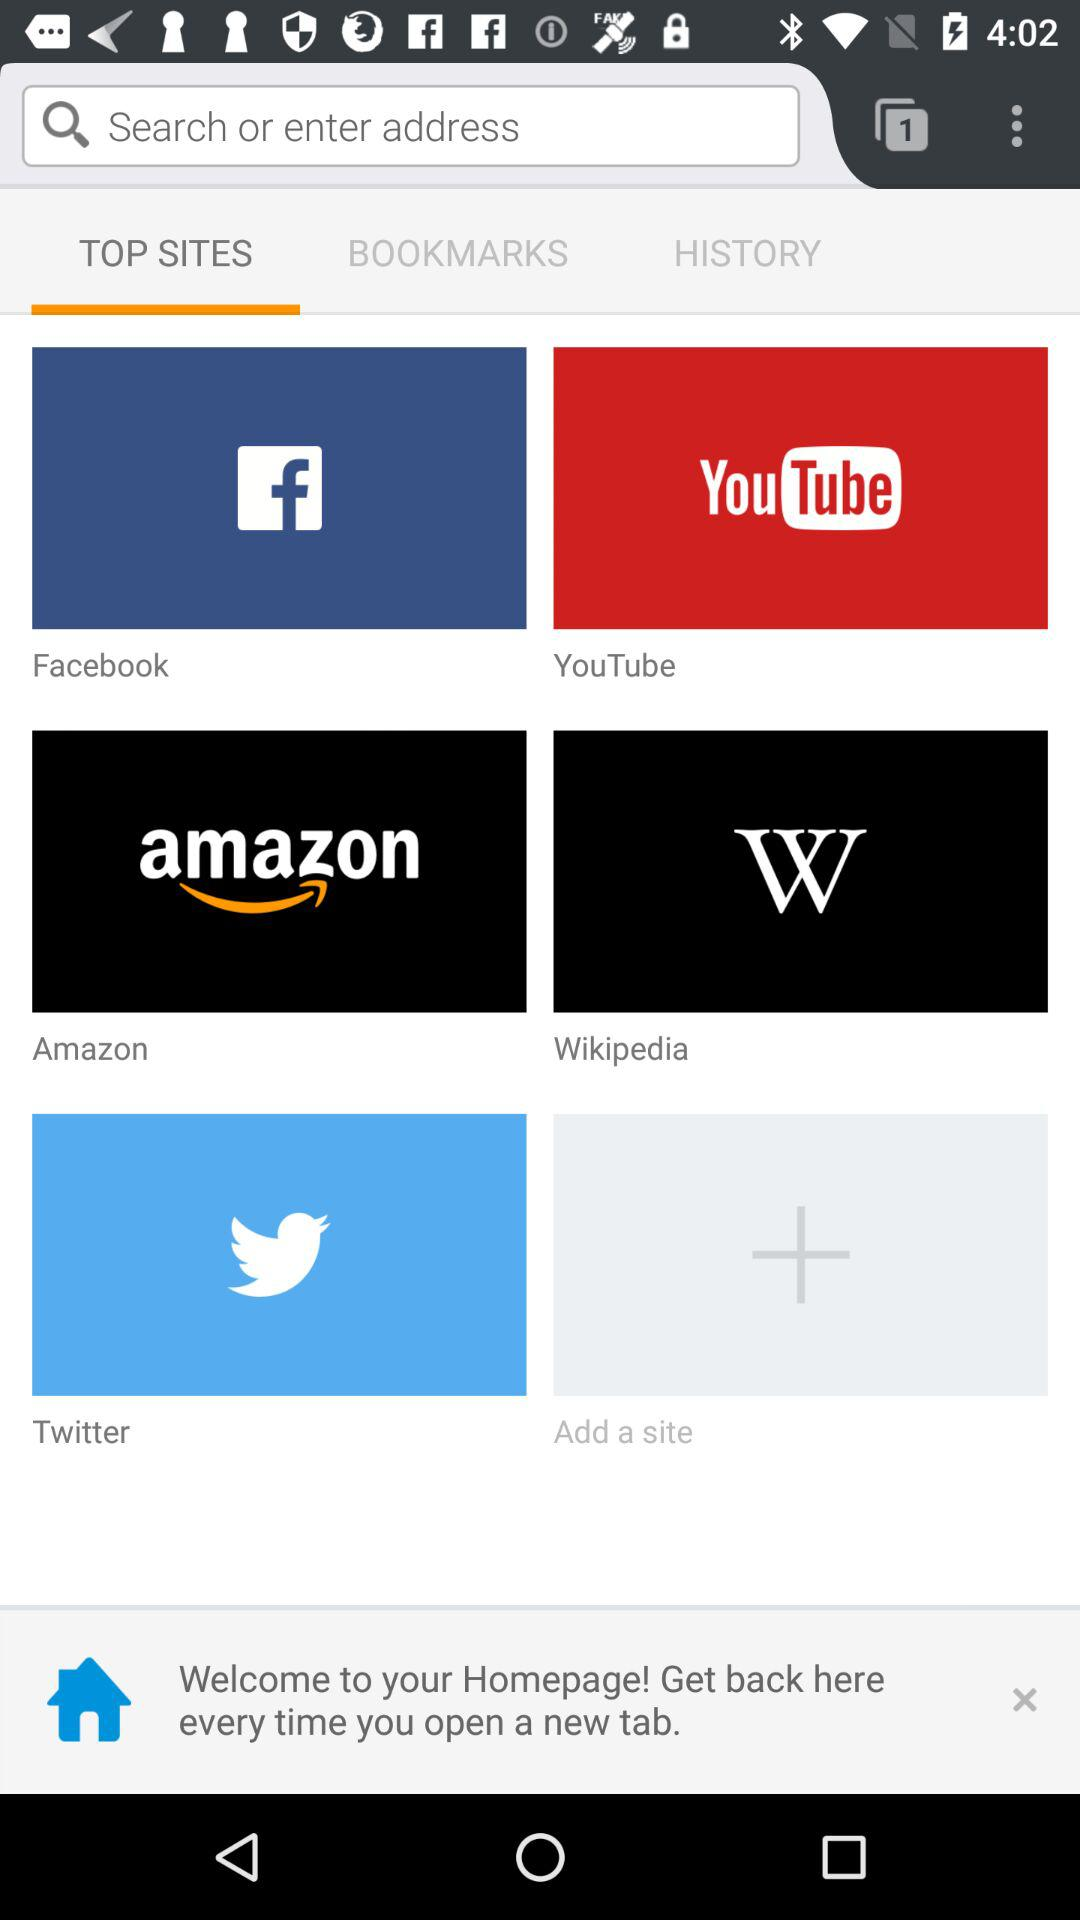Which websites are bookmarked?
When the provided information is insufficient, respond with <no answer>. <no answer> 